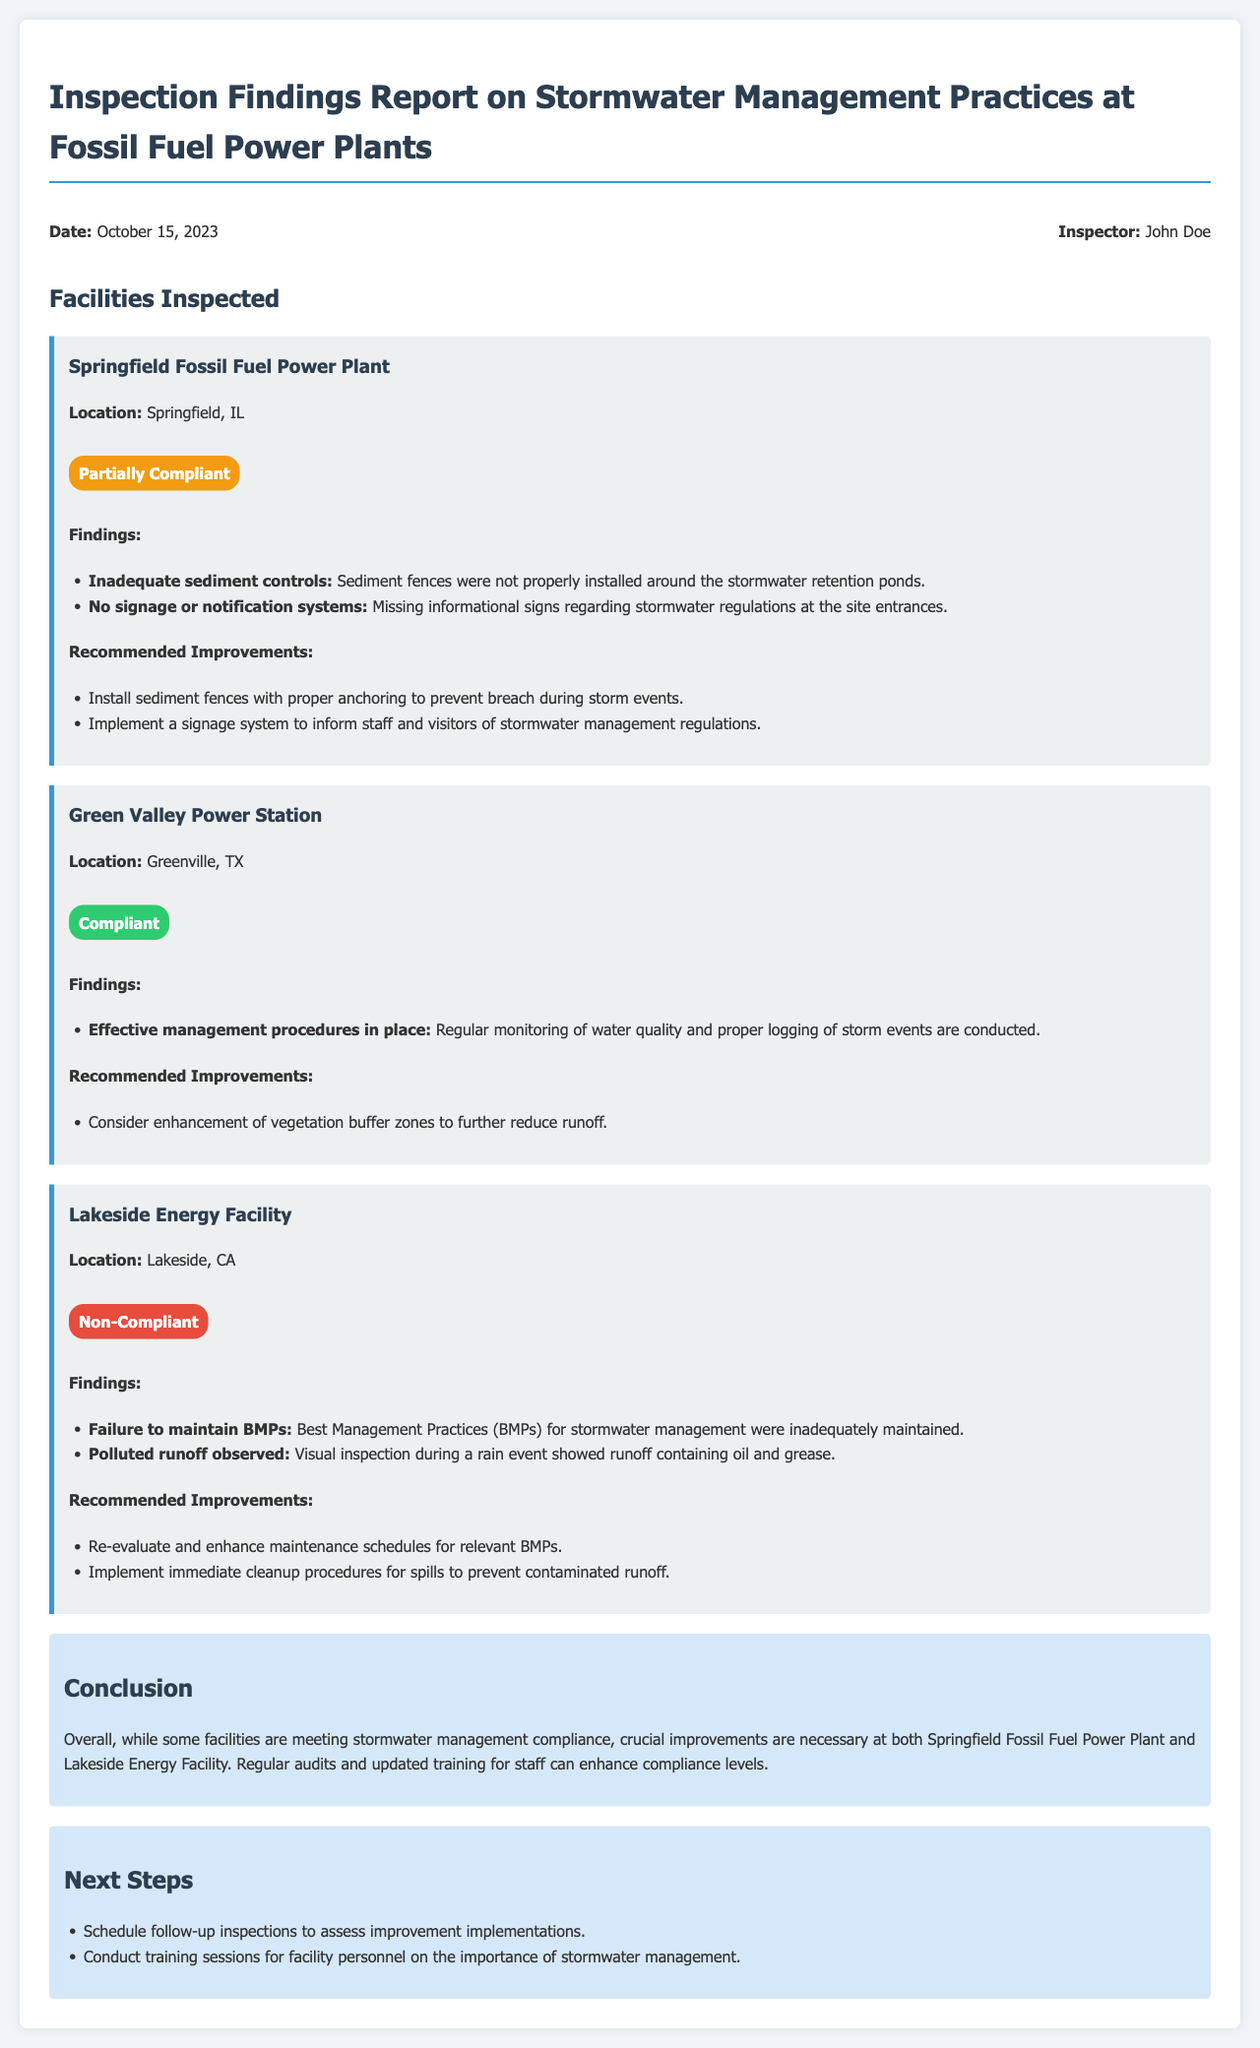what is the date of the inspection? The inspection date is mentioned prominently at the top of the report.
Answer: October 15, 2023 who is the inspector? The inspector's name is displayed in the header section of the report.
Answer: John Doe how many facilities are inspected in the report? The report lists three different facilities that were inspected.
Answer: Three what is the compliance status of Lakeside Energy Facility? The compliance status is indicated in bold near the facility description.
Answer: Non-Compliant what recommendation is made for Green Valley Power Station? The recommended improvement is listed under the section for that facility.
Answer: Consider enhancement of vegetation buffer zones which facility had inadequate sediment controls? The findings include specific issues for each facility.
Answer: Springfield Fossil Fuel Power Plant what is suggested as a next step in the report? The next steps are outlined in a specific section towards the end.
Answer: Schedule follow-up inspections how many findings are listed for the Springfield Fossil Fuel Power Plant? The number of findings can be counted in the findings section for that facility.
Answer: Two what type of report is this? The title clearly states the nature of the document.
Answer: Inspection Findings Report 